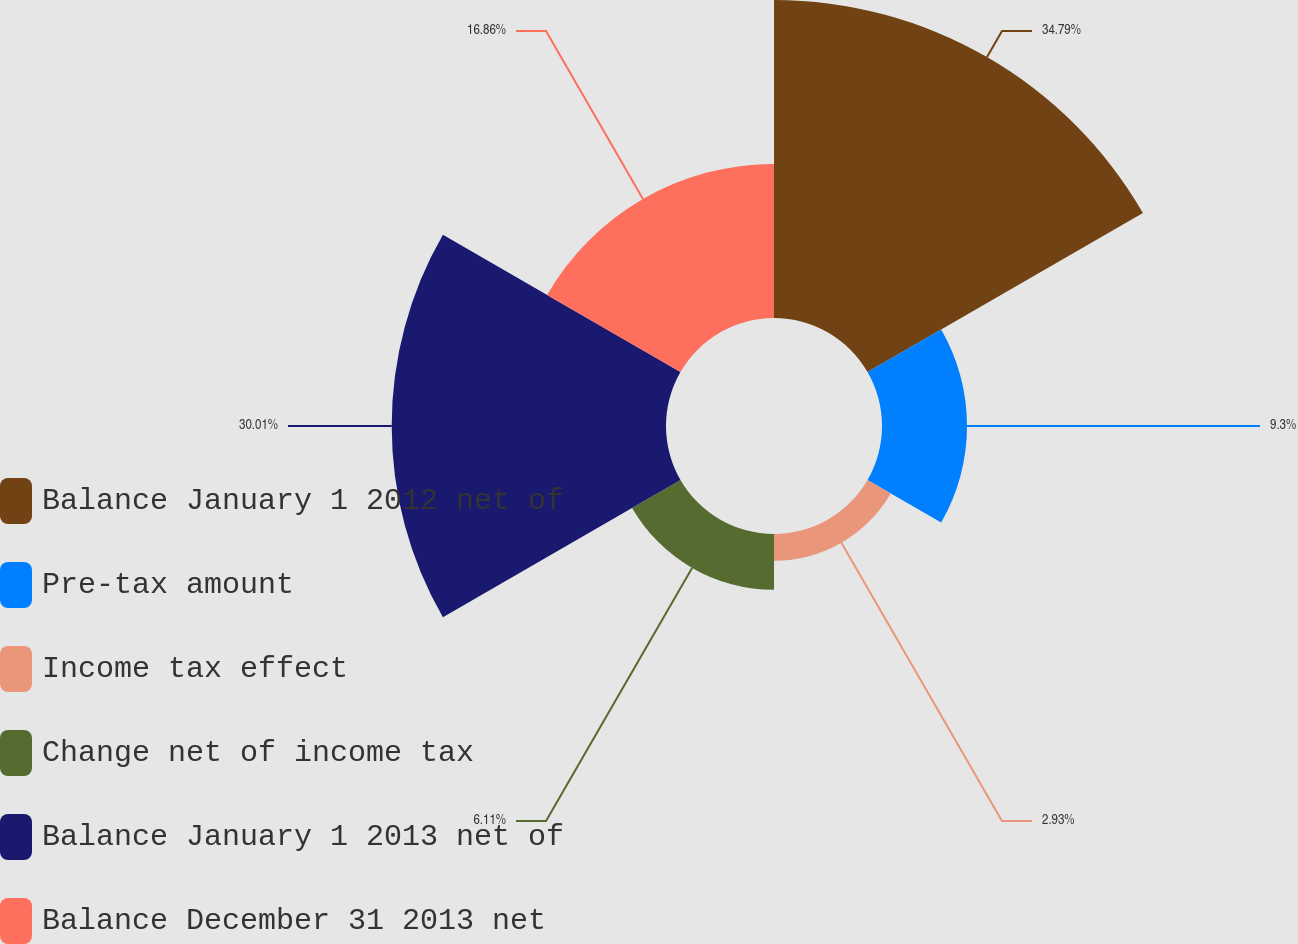Convert chart. <chart><loc_0><loc_0><loc_500><loc_500><pie_chart><fcel>Balance January 1 2012 net of<fcel>Pre-tax amount<fcel>Income tax effect<fcel>Change net of income tax<fcel>Balance January 1 2013 net of<fcel>Balance December 31 2013 net<nl><fcel>34.79%<fcel>9.3%<fcel>2.93%<fcel>6.11%<fcel>30.01%<fcel>16.86%<nl></chart> 